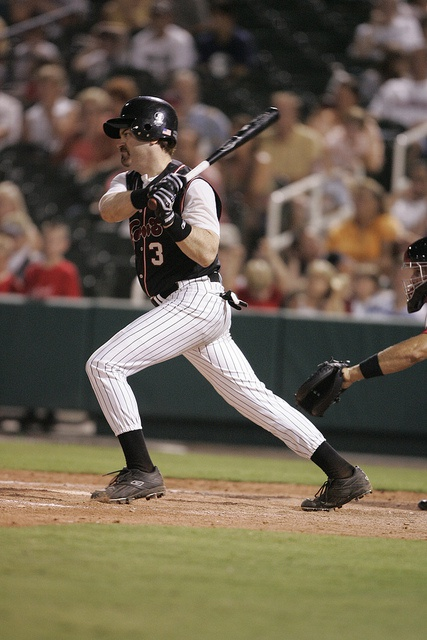Describe the objects in this image and their specific colors. I can see people in black, lightgray, darkgray, and gray tones, people in black, brown, and gray tones, people in black, gray, and brown tones, people in black, gray, maroon, and tan tones, and people in black, gray, brown, and maroon tones in this image. 